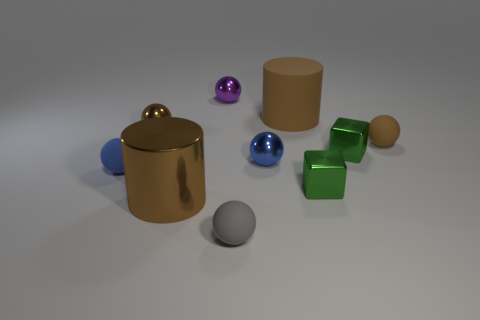Is there a shiny cylinder behind the big metallic cylinder on the left side of the brown rubber cylinder?
Make the answer very short. No. How many large brown matte objects are there?
Offer a terse response. 1. There is a tiny matte object that is on the right side of the tiny purple shiny sphere and behind the gray matte ball; what is its color?
Provide a succinct answer. Brown. There is a brown matte object that is the same shape as the tiny brown metallic thing; what is its size?
Make the answer very short. Small. What number of other balls have the same size as the blue matte sphere?
Keep it short and to the point. 5. What material is the small purple object?
Give a very brief answer. Metal. There is a tiny blue rubber sphere; are there any small blue matte spheres behind it?
Ensure brevity in your answer.  No. What is the size of the brown sphere that is made of the same material as the small gray sphere?
Offer a very short reply. Small. How many small metallic blocks have the same color as the big shiny cylinder?
Keep it short and to the point. 0. Is the number of brown metallic cylinders that are right of the large metal cylinder less than the number of small gray balls that are behind the tiny brown matte sphere?
Keep it short and to the point. No. 